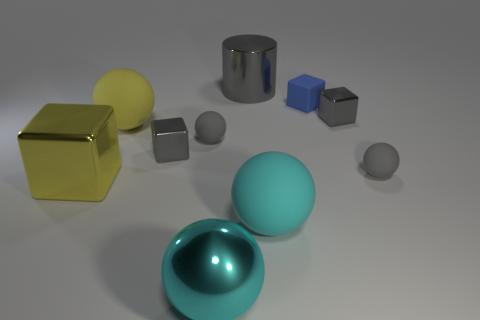Is there a large metallic thing of the same shape as the small blue thing?
Offer a very short reply. Yes. Is the color of the big matte object that is in front of the big metallic block the same as the small rubber cube?
Offer a very short reply. No. Do the blue cube that is on the right side of the big gray metallic object and the metallic object that is left of the yellow ball have the same size?
Provide a short and direct response. No. There is a cyan ball that is the same material as the small blue object; what size is it?
Give a very brief answer. Large. How many tiny cubes are right of the large cyan metal sphere and on the left side of the large cylinder?
Your answer should be compact. 0. What number of objects are either large objects or large rubber balls left of the metal ball?
Offer a very short reply. 5. There is a rubber object that is the same color as the metal ball; what shape is it?
Provide a short and direct response. Sphere. There is a big rubber ball that is behind the big yellow shiny thing; what is its color?
Provide a short and direct response. Yellow. How many things are either big objects that are in front of the large gray cylinder or small green metal spheres?
Give a very brief answer. 4. There is a cylinder that is the same size as the cyan matte ball; what color is it?
Offer a very short reply. Gray. 